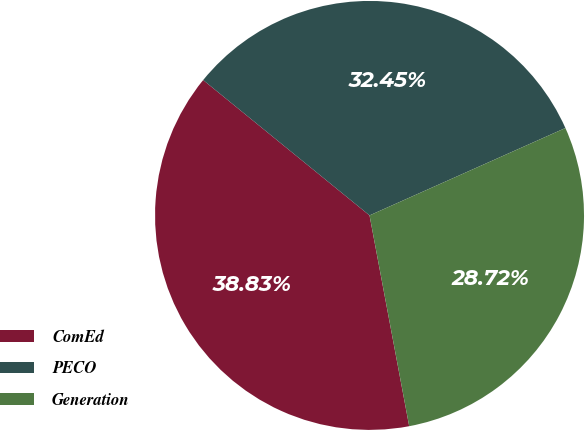<chart> <loc_0><loc_0><loc_500><loc_500><pie_chart><fcel>ComEd<fcel>PECO<fcel>Generation<nl><fcel>38.83%<fcel>32.45%<fcel>28.72%<nl></chart> 